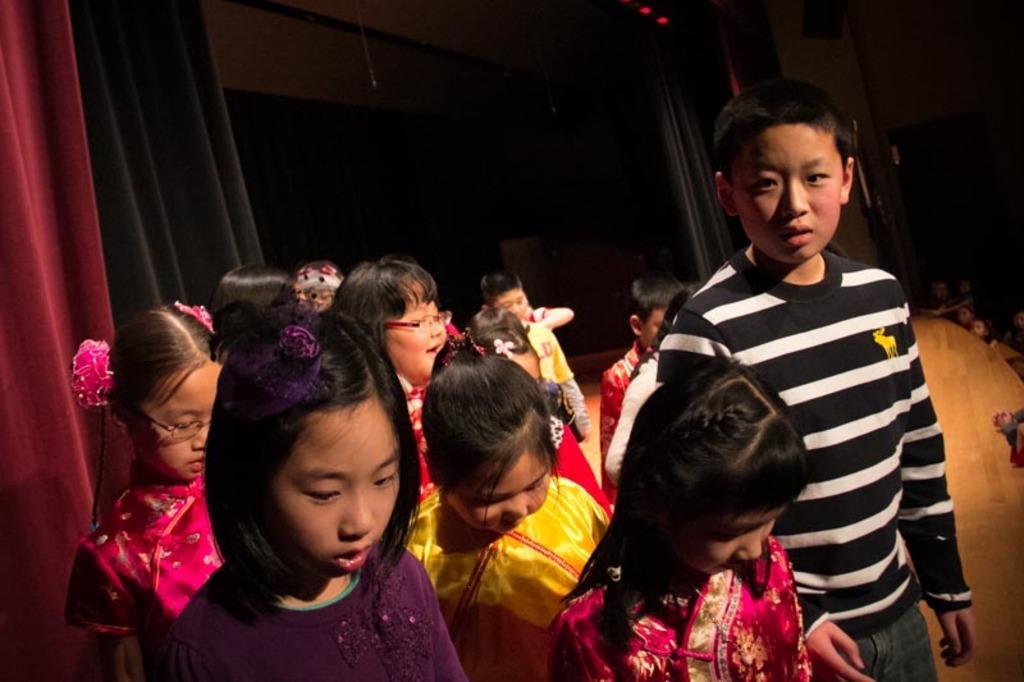In one or two sentences, can you explain what this image depicts? In this image I can see number of children are standing on the stage which is brown in color. I can see few curtains which are red and black in color. In the background I can see few persons and the dark background. 